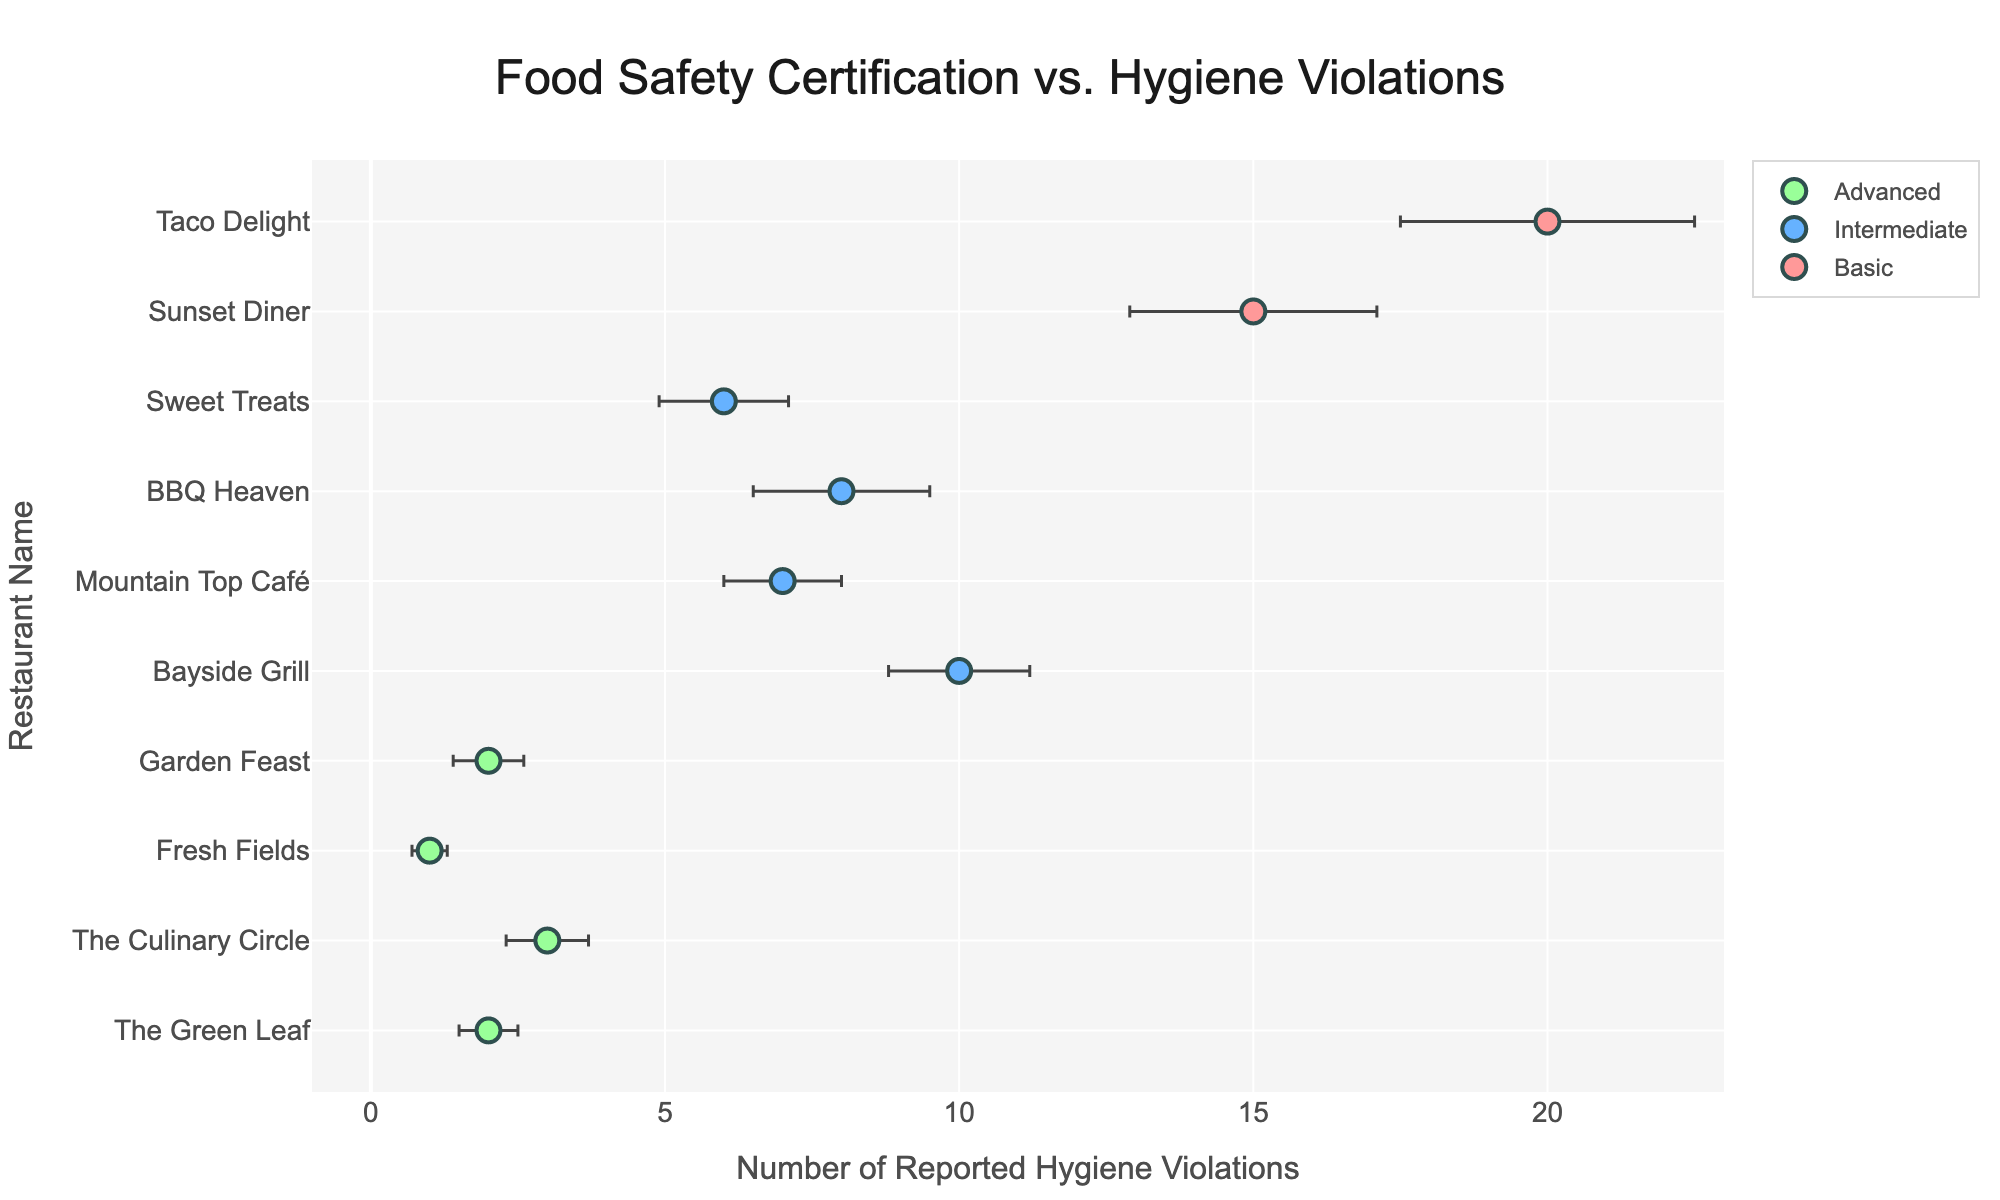What is the title of the figure? The title of the figure can be found at the top and is often displayed in a larger font size to grab attention. The title here is centered and specifies the relationship between food safety certification levels and hygiene violations.
Answer: Food Safety Certification vs. Hygiene Violations How many restaurants are listed in the figure? To find the number of restaurants, one should count the unique data points or markers in the scatter plot, each representing a restaurant.
Answer: 10 Which restaurant has the highest number of reported hygiene violations? Look at the x-axis values corresponding to the highest points. The restaurant with the furthest point on the right will have the most violations, which is labeled as 'Taco Delight'.
Answer: Taco Delight What is the x-axis title in the figure? The x-axis title is typically found below the horizontal axis and indicates what the axis is measuring. Here it specifies the measure as the number of reported hygiene violations.
Answer: Number of Reported Hygiene Violations Which region has the restaurant with the fewest hygiene violations? Identify the restaurant name accompanying the smallest x-value or point closest to the origin on the x-axis, which is labeled as 'Fresh Fields' from the 'Northeast' region.
Answer: Northeast Which certification level is associated with the lowest number of hygiene violations? Look for the cluster of points that have the lowest x-axis values and identify what certification level they represent by their color.
Answer: Advanced Compare the number of hygiene violations between 'Bayside Grill' and 'Mountain Top Café'. Which one has fewer violations? Locate 'Bayside Grill' and 'Mountain Top Café' on the y-axis, then compare their corresponding x-values. 'Mountain Top Café' has a lower value than 'Bayside Grill'.
Answer: Mountain Top Café If we average the hygiene violations of restaurants with 'Intermediate' certification, what is the result? Sum the x-axis values of all points representing 'Intermediate' certification and divide by the number of such data points. (10 + 7 + 8 + 6) / 4 = 7.75
Answer: 7.75 What is the color representing 'Basic' certification levels in the plot? Each certification level has a unique color for easy identification. Looking at the legend, 'Basic' certification is represented by a specific color.
Answer: Red Among the restaurants with 'Advanced' certification, which one has the closest number of violations to 'The Culinary Circle'? Compare the x-values of all 'Advanced' certification restaurants and identify the one closest to 'The Culinary Circle' (which is 3). 'The Green Leaf' is the closest with 2 violations.
Answer: The Green Leaf 